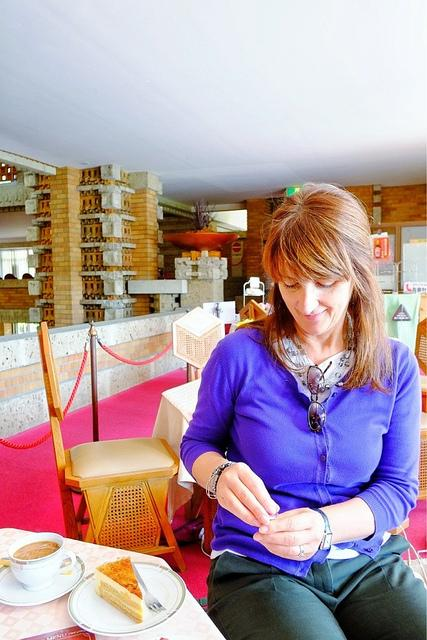Why is the woman sitting? eating 